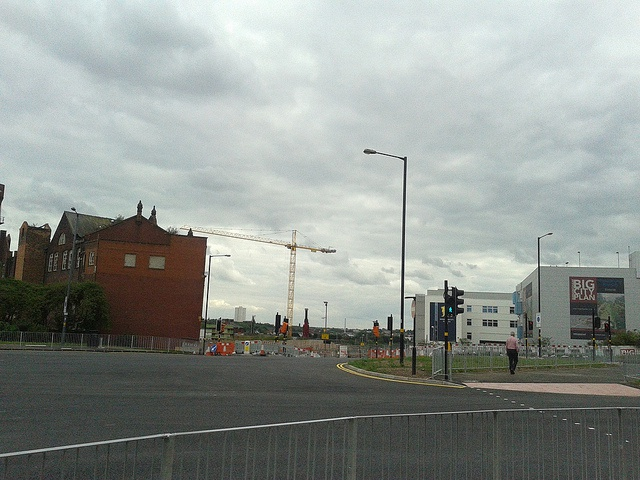Describe the objects in this image and their specific colors. I can see traffic light in lightgray, black, gray, and darkgray tones, people in lightgray, black, and gray tones, traffic light in black, gray, darkgray, and lightgray tones, traffic light in black and lightgray tones, and traffic light in lightgray, black, gray, and maroon tones in this image. 